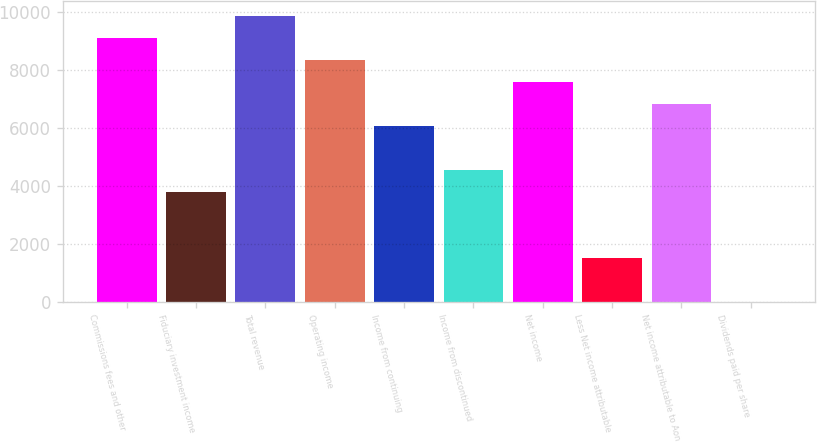Convert chart. <chart><loc_0><loc_0><loc_500><loc_500><bar_chart><fcel>Commissions fees and other<fcel>Fiduciary investment income<fcel>Total revenue<fcel>Operating income<fcel>Income from continuing<fcel>Income from discontinued<fcel>Net income<fcel>Less Net income attributable<fcel>Net income attributable to Aon<fcel>Dividends paid per share<nl><fcel>9113.88<fcel>3797.8<fcel>9873.32<fcel>8354.44<fcel>6076.12<fcel>4557.24<fcel>7595<fcel>1519.48<fcel>6835.56<fcel>0.6<nl></chart> 